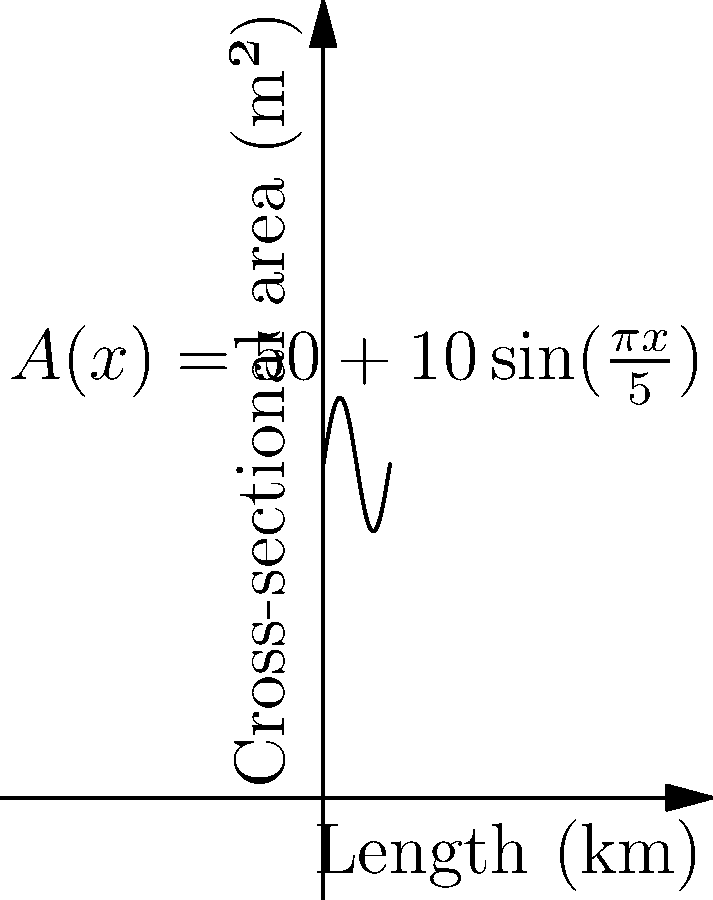A reservoir's cross-sectional area $A(x)$ in square meters varies along its length $x$ in kilometers according to the function $A(x) = 50 + 10\sin(\frac{\pi x}{5})$, where $0 \leq x \leq 10$. Calculate the total volume of water in the reservoir in cubic meters. To find the total volume of water in the reservoir, we need to integrate the cross-sectional area function over the length of the reservoir. This is a perfect application of the definite integral.

Step 1: Set up the definite integral
$$V = \int_0^{10} A(x) dx = \int_0^{10} (50 + 10\sin(\frac{\pi x}{5})) dx$$

Step 2: Integrate the function
$$V = \left[50x - \frac{50}{\pi}\cos(\frac{\pi x}{5})\right]_0^{10}$$

Step 3: Evaluate the integral at the limits
$$V = \left(500 - \frac{50}{\pi}\cos(2\pi)\right) - \left(0 - \frac{50}{\pi}\cos(0)\right)$$

Step 4: Simplify
$$V = 500 - \frac{50}{\pi} + \frac{50}{\pi} = 500$$

Step 5: Interpret the result
The volume is 500 cubic kilometers. To convert to cubic meters:
$$500 \text{ km}^3 \times (1000 \text{ m}/\text{km})^3 = 500,000,000,000 \text{ m}^3$$

Therefore, the total volume of water in the reservoir is 500 billion cubic meters.
Answer: 500 billion m³ 